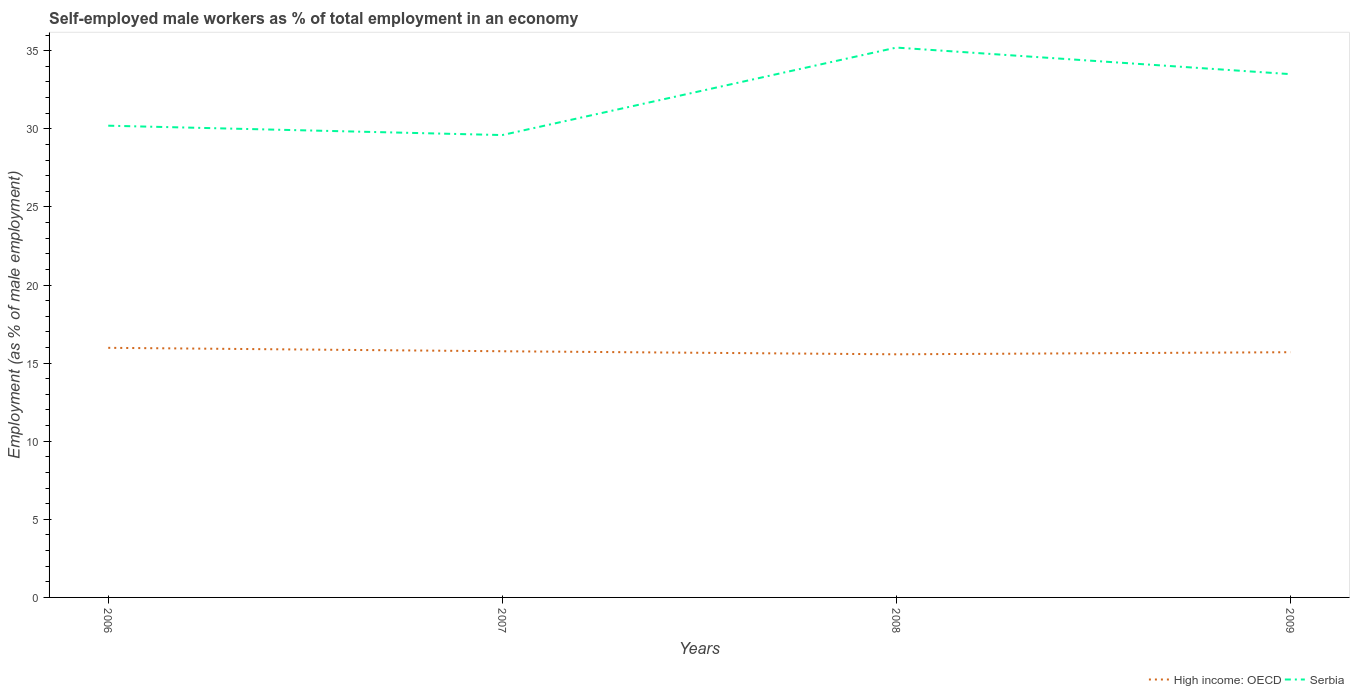Is the number of lines equal to the number of legend labels?
Provide a succinct answer. Yes. Across all years, what is the maximum percentage of self-employed male workers in Serbia?
Provide a succinct answer. 29.6. What is the total percentage of self-employed male workers in High income: OECD in the graph?
Provide a succinct answer. 0.42. What is the difference between the highest and the second highest percentage of self-employed male workers in Serbia?
Make the answer very short. 5.6. Is the percentage of self-employed male workers in High income: OECD strictly greater than the percentage of self-employed male workers in Serbia over the years?
Offer a very short reply. Yes. How many lines are there?
Provide a succinct answer. 2. What is the difference between two consecutive major ticks on the Y-axis?
Your response must be concise. 5. Does the graph contain any zero values?
Provide a short and direct response. No. Does the graph contain grids?
Provide a succinct answer. No. Where does the legend appear in the graph?
Give a very brief answer. Bottom right. What is the title of the graph?
Provide a succinct answer. Self-employed male workers as % of total employment in an economy. What is the label or title of the X-axis?
Provide a succinct answer. Years. What is the label or title of the Y-axis?
Your response must be concise. Employment (as % of male employment). What is the Employment (as % of male employment) of High income: OECD in 2006?
Ensure brevity in your answer.  15.98. What is the Employment (as % of male employment) in Serbia in 2006?
Give a very brief answer. 30.2. What is the Employment (as % of male employment) in High income: OECD in 2007?
Your answer should be compact. 15.76. What is the Employment (as % of male employment) of Serbia in 2007?
Offer a very short reply. 29.6. What is the Employment (as % of male employment) in High income: OECD in 2008?
Ensure brevity in your answer.  15.56. What is the Employment (as % of male employment) in Serbia in 2008?
Your answer should be compact. 35.2. What is the Employment (as % of male employment) of High income: OECD in 2009?
Ensure brevity in your answer.  15.7. What is the Employment (as % of male employment) in Serbia in 2009?
Make the answer very short. 33.5. Across all years, what is the maximum Employment (as % of male employment) in High income: OECD?
Your answer should be very brief. 15.98. Across all years, what is the maximum Employment (as % of male employment) in Serbia?
Ensure brevity in your answer.  35.2. Across all years, what is the minimum Employment (as % of male employment) in High income: OECD?
Provide a short and direct response. 15.56. Across all years, what is the minimum Employment (as % of male employment) in Serbia?
Ensure brevity in your answer.  29.6. What is the total Employment (as % of male employment) in High income: OECD in the graph?
Offer a terse response. 63. What is the total Employment (as % of male employment) of Serbia in the graph?
Provide a succinct answer. 128.5. What is the difference between the Employment (as % of male employment) in High income: OECD in 2006 and that in 2007?
Your answer should be very brief. 0.22. What is the difference between the Employment (as % of male employment) of High income: OECD in 2006 and that in 2008?
Your answer should be very brief. 0.42. What is the difference between the Employment (as % of male employment) of Serbia in 2006 and that in 2008?
Make the answer very short. -5. What is the difference between the Employment (as % of male employment) in High income: OECD in 2006 and that in 2009?
Ensure brevity in your answer.  0.28. What is the difference between the Employment (as % of male employment) of High income: OECD in 2007 and that in 2008?
Ensure brevity in your answer.  0.2. What is the difference between the Employment (as % of male employment) of High income: OECD in 2007 and that in 2009?
Provide a short and direct response. 0.06. What is the difference between the Employment (as % of male employment) of Serbia in 2007 and that in 2009?
Provide a succinct answer. -3.9. What is the difference between the Employment (as % of male employment) of High income: OECD in 2008 and that in 2009?
Your response must be concise. -0.13. What is the difference between the Employment (as % of male employment) in Serbia in 2008 and that in 2009?
Ensure brevity in your answer.  1.7. What is the difference between the Employment (as % of male employment) in High income: OECD in 2006 and the Employment (as % of male employment) in Serbia in 2007?
Your answer should be compact. -13.62. What is the difference between the Employment (as % of male employment) in High income: OECD in 2006 and the Employment (as % of male employment) in Serbia in 2008?
Make the answer very short. -19.22. What is the difference between the Employment (as % of male employment) of High income: OECD in 2006 and the Employment (as % of male employment) of Serbia in 2009?
Your answer should be very brief. -17.52. What is the difference between the Employment (as % of male employment) of High income: OECD in 2007 and the Employment (as % of male employment) of Serbia in 2008?
Keep it short and to the point. -19.44. What is the difference between the Employment (as % of male employment) in High income: OECD in 2007 and the Employment (as % of male employment) in Serbia in 2009?
Offer a very short reply. -17.74. What is the difference between the Employment (as % of male employment) of High income: OECD in 2008 and the Employment (as % of male employment) of Serbia in 2009?
Your response must be concise. -17.94. What is the average Employment (as % of male employment) of High income: OECD per year?
Your response must be concise. 15.75. What is the average Employment (as % of male employment) of Serbia per year?
Your response must be concise. 32.12. In the year 2006, what is the difference between the Employment (as % of male employment) in High income: OECD and Employment (as % of male employment) in Serbia?
Give a very brief answer. -14.22. In the year 2007, what is the difference between the Employment (as % of male employment) of High income: OECD and Employment (as % of male employment) of Serbia?
Provide a succinct answer. -13.84. In the year 2008, what is the difference between the Employment (as % of male employment) in High income: OECD and Employment (as % of male employment) in Serbia?
Provide a succinct answer. -19.64. In the year 2009, what is the difference between the Employment (as % of male employment) in High income: OECD and Employment (as % of male employment) in Serbia?
Ensure brevity in your answer.  -17.8. What is the ratio of the Employment (as % of male employment) of High income: OECD in 2006 to that in 2007?
Your response must be concise. 1.01. What is the ratio of the Employment (as % of male employment) of Serbia in 2006 to that in 2007?
Offer a very short reply. 1.02. What is the ratio of the Employment (as % of male employment) of High income: OECD in 2006 to that in 2008?
Ensure brevity in your answer.  1.03. What is the ratio of the Employment (as % of male employment) in Serbia in 2006 to that in 2008?
Your response must be concise. 0.86. What is the ratio of the Employment (as % of male employment) of High income: OECD in 2006 to that in 2009?
Your response must be concise. 1.02. What is the ratio of the Employment (as % of male employment) of Serbia in 2006 to that in 2009?
Keep it short and to the point. 0.9. What is the ratio of the Employment (as % of male employment) of High income: OECD in 2007 to that in 2008?
Your answer should be compact. 1.01. What is the ratio of the Employment (as % of male employment) in Serbia in 2007 to that in 2008?
Make the answer very short. 0.84. What is the ratio of the Employment (as % of male employment) in Serbia in 2007 to that in 2009?
Offer a terse response. 0.88. What is the ratio of the Employment (as % of male employment) in Serbia in 2008 to that in 2009?
Give a very brief answer. 1.05. What is the difference between the highest and the second highest Employment (as % of male employment) of High income: OECD?
Your response must be concise. 0.22. What is the difference between the highest and the second highest Employment (as % of male employment) in Serbia?
Give a very brief answer. 1.7. What is the difference between the highest and the lowest Employment (as % of male employment) of High income: OECD?
Ensure brevity in your answer.  0.42. What is the difference between the highest and the lowest Employment (as % of male employment) in Serbia?
Offer a very short reply. 5.6. 